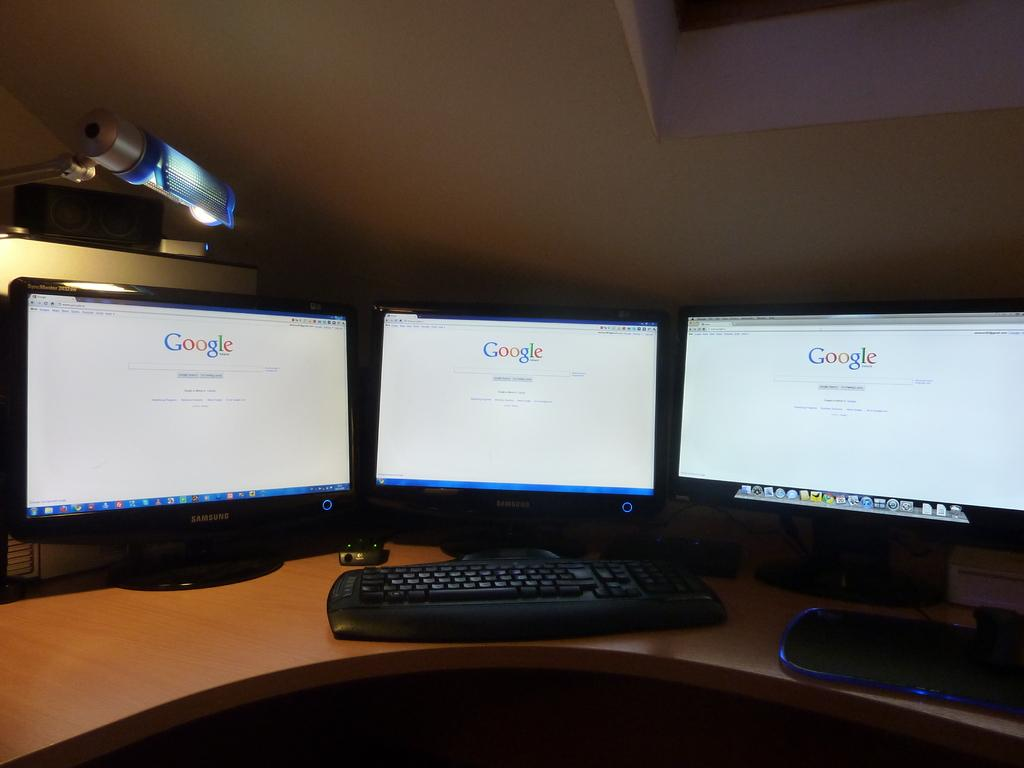Provide a one-sentence caption for the provided image. Three computers screen are all turned onto Google. 